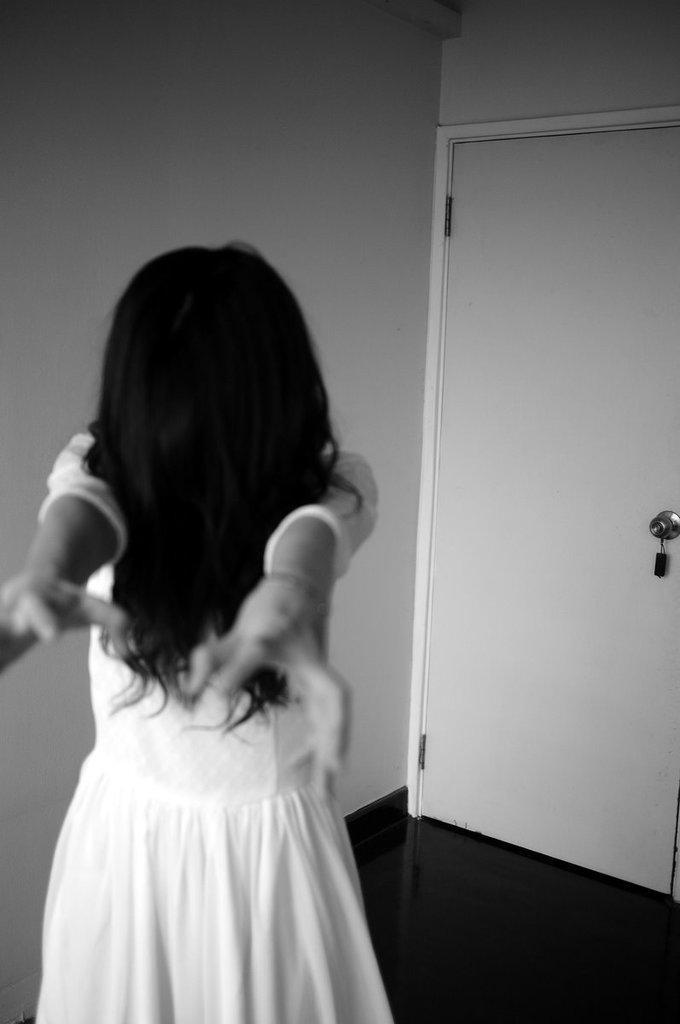How would you summarize this image in a sentence or two? In this image I can see a woman wearing a white color dress and I can see the wall and the door. 